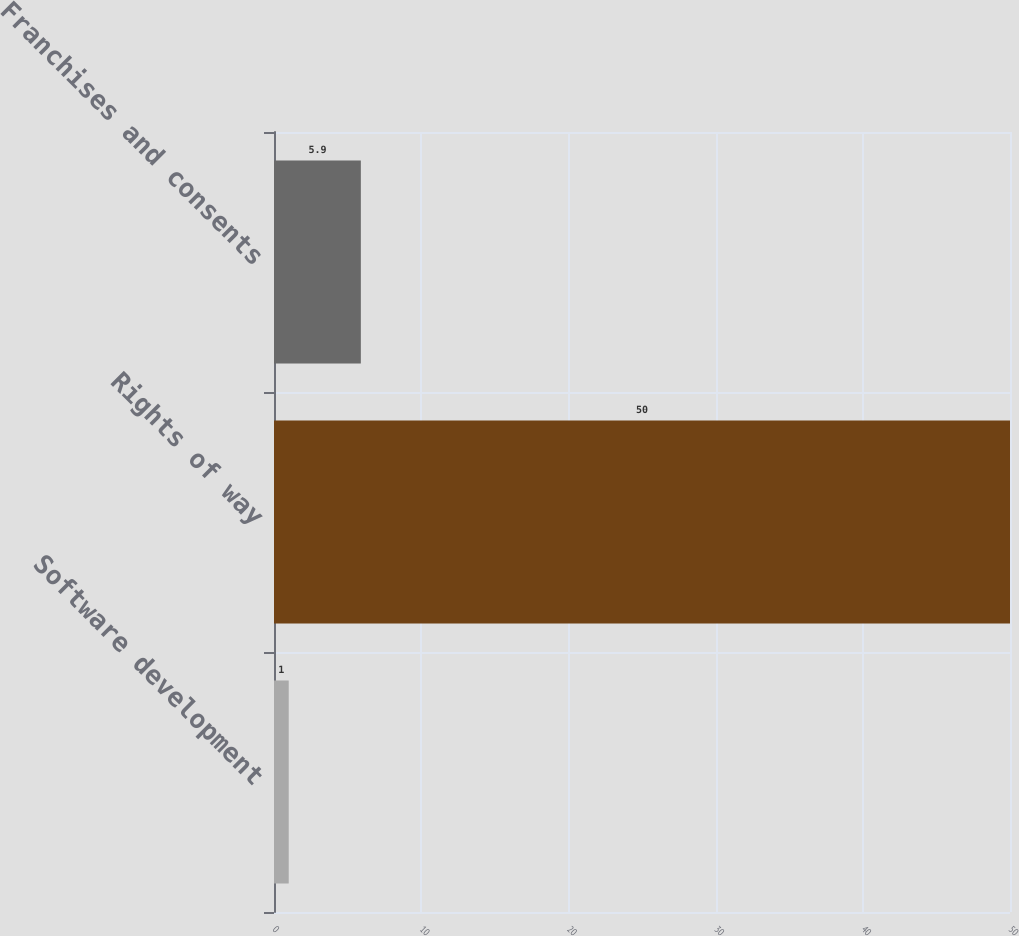Convert chart. <chart><loc_0><loc_0><loc_500><loc_500><bar_chart><fcel>Software development<fcel>Rights of way<fcel>Franchises and consents<nl><fcel>1<fcel>50<fcel>5.9<nl></chart> 